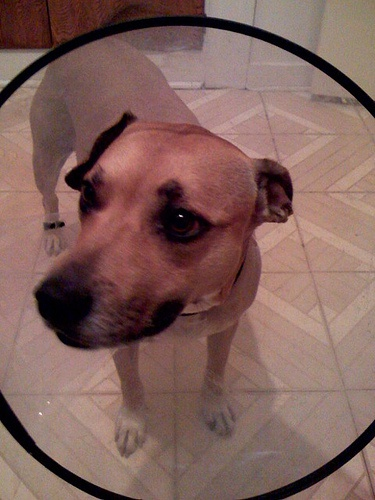Describe the objects in this image and their specific colors. I can see a dog in maroon, brown, and black tones in this image. 